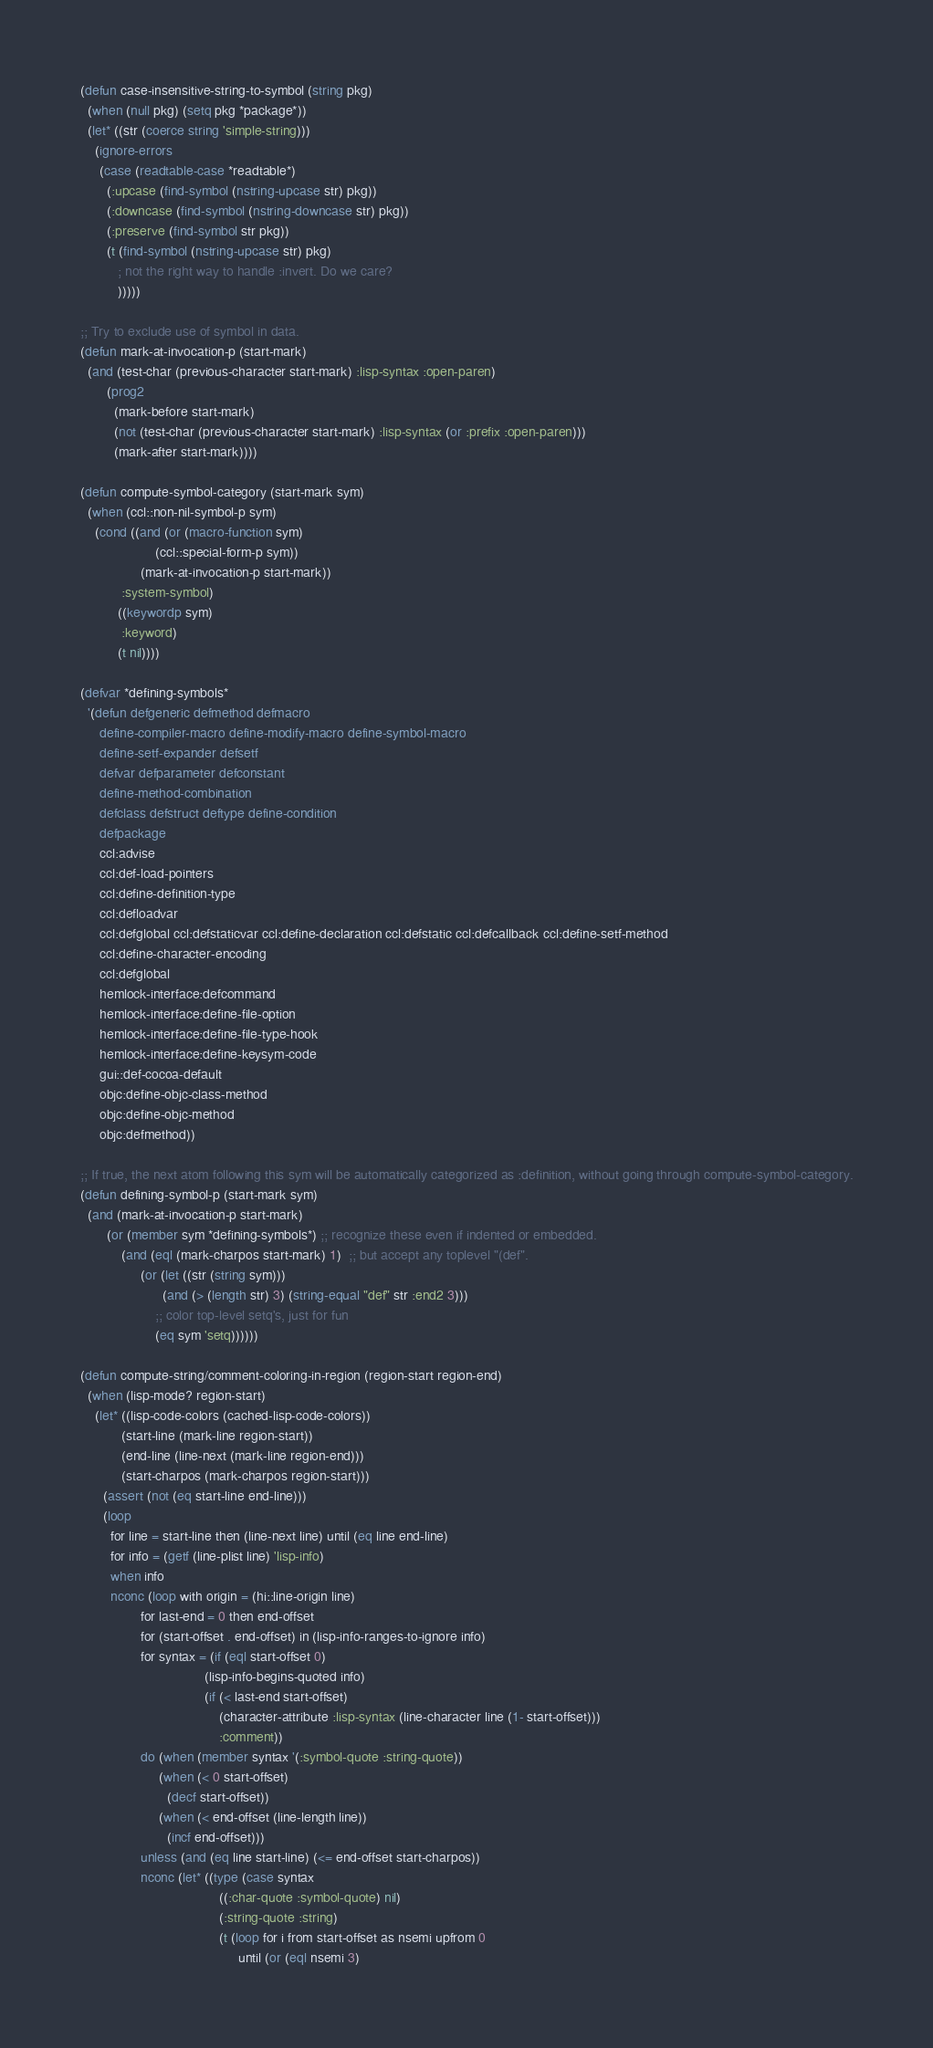<code> <loc_0><loc_0><loc_500><loc_500><_Lisp_>(defun case-insensitive-string-to-symbol (string pkg)
  (when (null pkg) (setq pkg *package*))
  (let* ((str (coerce string 'simple-string)))
    (ignore-errors 
     (case (readtable-case *readtable*)
       (:upcase (find-symbol (nstring-upcase str) pkg))
       (:downcase (find-symbol (nstring-downcase str) pkg))
       (:preserve (find-symbol str pkg))
       (t (find-symbol (nstring-upcase str) pkg)
          ; not the right way to handle :invert. Do we care?
          )))))

;; Try to exclude use of symbol in data.
(defun mark-at-invocation-p (start-mark)
  (and (test-char (previous-character start-mark) :lisp-syntax :open-paren)
       (prog2
         (mark-before start-mark)
         (not (test-char (previous-character start-mark) :lisp-syntax (or :prefix :open-paren)))
         (mark-after start-mark))))

(defun compute-symbol-category (start-mark sym)
  (when (ccl::non-nil-symbol-p sym)
    (cond ((and (or (macro-function sym)
                    (ccl::special-form-p sym))
                (mark-at-invocation-p start-mark))
           :system-symbol)
          ((keywordp sym)
           :keyword)
          (t nil))))

(defvar *defining-symbols*
  '(defun defgeneric defmethod defmacro
     define-compiler-macro define-modify-macro define-symbol-macro
     define-setf-expander defsetf 
     defvar defparameter defconstant
     define-method-combination
     defclass defstruct deftype define-condition
     defpackage
     ccl:advise
     ccl:def-load-pointers 
     ccl:define-definition-type
     ccl:defloadvar
     ccl:defglobal ccl:defstaticvar ccl:define-declaration ccl:defstatic ccl:defcallback ccl:define-setf-method
     ccl:define-character-encoding
     ccl:defglobal
     hemlock-interface:defcommand
     hemlock-interface:define-file-option 
     hemlock-interface:define-file-type-hook
     hemlock-interface:define-keysym-code
     gui::def-cocoa-default
     objc:define-objc-class-method
     objc:define-objc-method
     objc:defmethod))

;; If true, the next atom following this sym will be automatically categorized as :definition, without going through compute-symbol-category.
(defun defining-symbol-p (start-mark sym)
  (and (mark-at-invocation-p start-mark)
       (or (member sym *defining-symbols*) ;; recognize these even if indented or embedded.
           (and (eql (mark-charpos start-mark) 1)  ;; but accept any toplevel "(def".
                (or (let ((str (string sym)))
                      (and (> (length str) 3) (string-equal "def" str :end2 3)))
                    ;; color top-level setq's, just for fun
                    (eq sym 'setq))))))

(defun compute-string/comment-coloring-in-region (region-start region-end)
  (when (lisp-mode? region-start)
    (let* ((lisp-code-colors (cached-lisp-code-colors))
           (start-line (mark-line region-start))
           (end-line (line-next (mark-line region-end)))
           (start-charpos (mark-charpos region-start)))
      (assert (not (eq start-line end-line)))
      (loop
        for line = start-line then (line-next line) until (eq line end-line)
        for info = (getf (line-plist line) 'lisp-info)
        when info
        nconc (loop with origin = (hi::line-origin line)
                for last-end = 0 then end-offset
                for (start-offset . end-offset) in (lisp-info-ranges-to-ignore info)
                for syntax = (if (eql start-offset 0)
                                 (lisp-info-begins-quoted info)
                                 (if (< last-end start-offset)
                                     (character-attribute :lisp-syntax (line-character line (1- start-offset)))
                                     :comment))
                do (when (member syntax '(:symbol-quote :string-quote))
                     (when (< 0 start-offset)
                       (decf start-offset))
                     (when (< end-offset (line-length line))
                       (incf end-offset)))
                unless (and (eq line start-line) (<= end-offset start-charpos))
                nconc (let* ((type (case syntax
                                     ((:char-quote :symbol-quote) nil)
                                     (:string-quote :string)
                                     (t (loop for i from start-offset as nsemi upfrom 0
                                          until (or (eql nsemi 3)</code> 